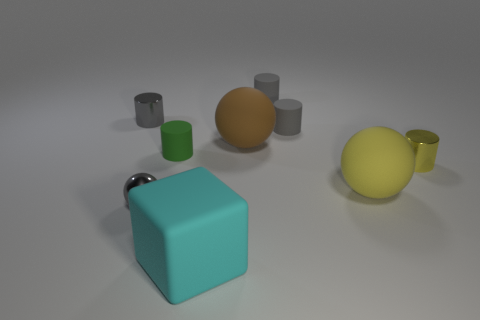Subtract all gray spheres. How many gray cylinders are left? 3 Subtract 1 cylinders. How many cylinders are left? 4 Subtract all yellow cylinders. How many cylinders are left? 4 Subtract all tiny gray metal cylinders. How many cylinders are left? 4 Subtract all cyan cylinders. Subtract all brown blocks. How many cylinders are left? 5 Add 1 cyan things. How many objects exist? 10 Subtract all cylinders. How many objects are left? 4 Add 9 small green cylinders. How many small green cylinders are left? 10 Add 5 rubber spheres. How many rubber spheres exist? 7 Subtract 3 gray cylinders. How many objects are left? 6 